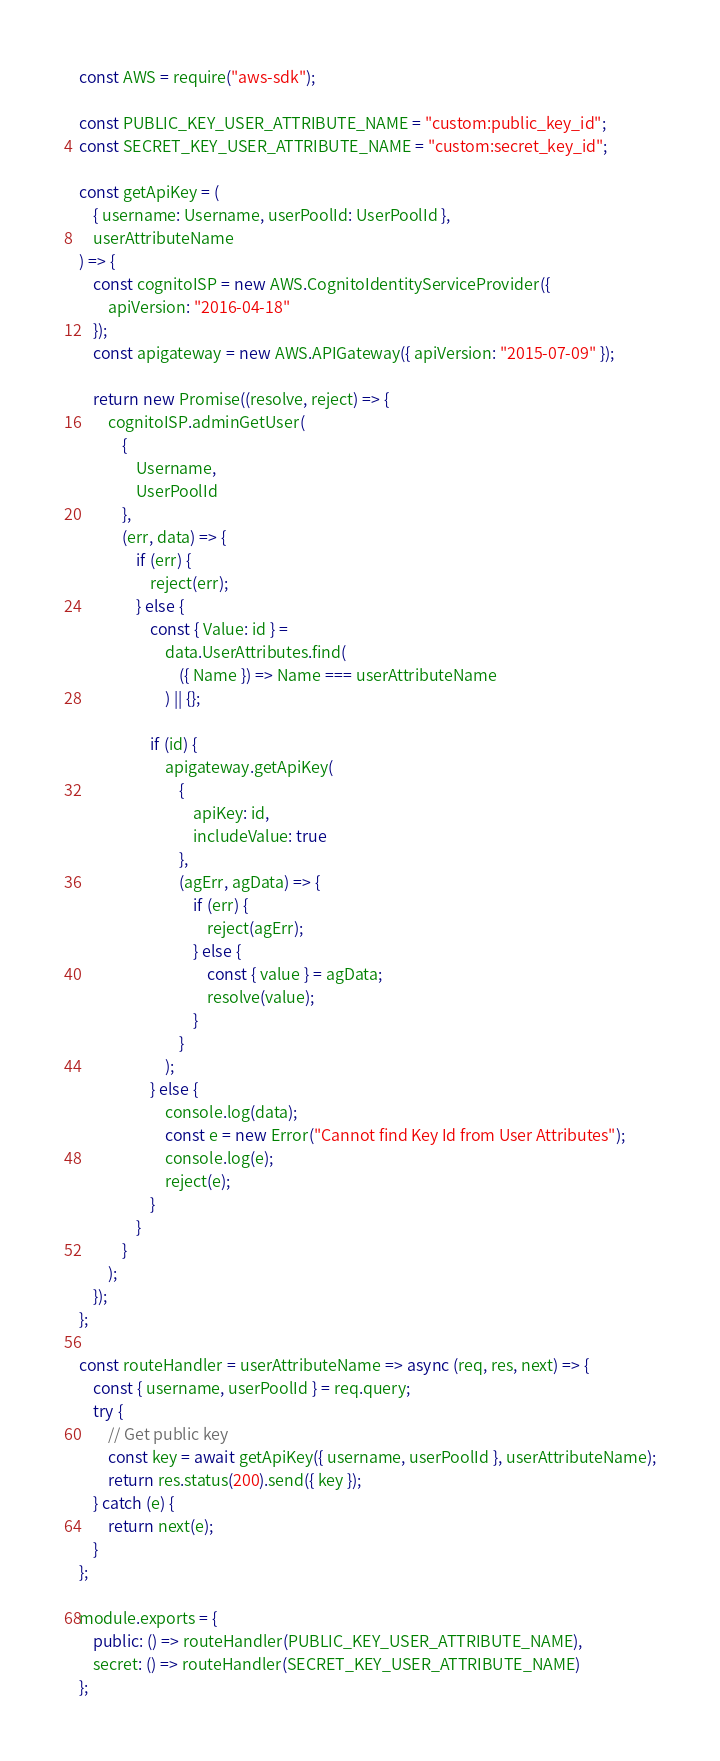Convert code to text. <code><loc_0><loc_0><loc_500><loc_500><_JavaScript_>const AWS = require("aws-sdk");

const PUBLIC_KEY_USER_ATTRIBUTE_NAME = "custom:public_key_id";
const SECRET_KEY_USER_ATTRIBUTE_NAME = "custom:secret_key_id";

const getApiKey = (
	{ username: Username, userPoolId: UserPoolId },
	userAttributeName
) => {
	const cognitoISP = new AWS.CognitoIdentityServiceProvider({
		apiVersion: "2016-04-18"
	});
	const apigateway = new AWS.APIGateway({ apiVersion: "2015-07-09" });

	return new Promise((resolve, reject) => {
		cognitoISP.adminGetUser(
			{
				Username,
				UserPoolId
			},
			(err, data) => {
				if (err) {
					reject(err);
				} else {
					const { Value: id } =
						data.UserAttributes.find(
							({ Name }) => Name === userAttributeName
						) || {};

					if (id) {
						apigateway.getApiKey(
							{
								apiKey: id,
								includeValue: true
							},
							(agErr, agData) => {
								if (err) {
									reject(agErr);
								} else {
									const { value } = agData;
									resolve(value);
								}
							}
						);
					} else {
						console.log(data);
						const e = new Error("Cannot find Key Id from User Attributes");
						console.log(e);
						reject(e);
					}
				}
			}
		);
	});
};

const routeHandler = userAttributeName => async (req, res, next) => {
	const { username, userPoolId } = req.query;
	try {
		// Get public key
		const key = await getApiKey({ username, userPoolId }, userAttributeName);
		return res.status(200).send({ key });
	} catch (e) {
		return next(e);
	}
};

module.exports = {
	public: () => routeHandler(PUBLIC_KEY_USER_ATTRIBUTE_NAME),
	secret: () => routeHandler(SECRET_KEY_USER_ATTRIBUTE_NAME)
};
</code> 